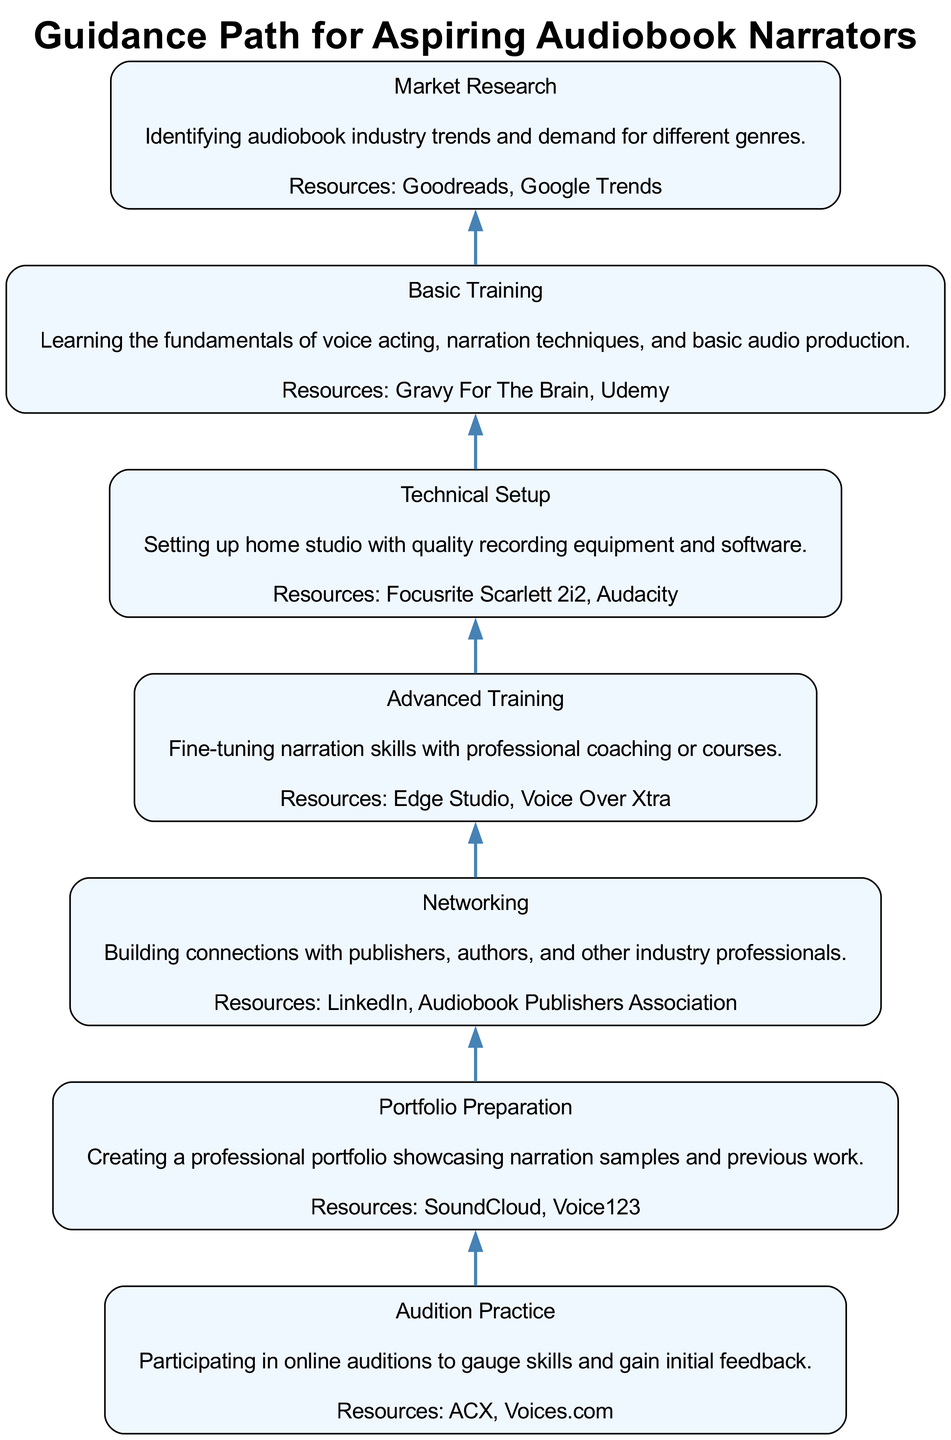What is the first step in the flow? The first step at the bottom of the diagram is "Market Research", as it represents the starting point for aspiring audiobook narrators before advancing to other skills and opportunities.
Answer: Market Research How many steps are there in total? By counting each individual step in the diagram from the bottom to the top, we find there are seven distinct steps listed, which guide aspiring narrators through their development and job search process.
Answer: 7 What is the last step in the flow? The last step at the top of the diagram is "Audition Practice", indicating the culminating activity where narrators can showcase their skills and receive feedback after acquiring various skills.
Answer: Audition Practice Which step directly precedes "Networking"? Upon reviewing the diagram, it is clear that "Portfolio Preparation" is the step that comes immediately before "Networking", indicating that narrators should prepare their portfolio prior to making industry connections.
Answer: Portfolio Preparation What type of resources are recommended for Basic Training? The diagram explicitly states that "Gravy For The Brain" and "Udemy" are the resources associated with the "Basic Training" step, which focuses on the fundamentals of narration techniques and acting.
Answer: Gravy For The Brain, Udemy What step involves setting up a home studio? In the diagram, "Technical Setup" is identified as the step focused on establishing a home recording environment with the necessary equipment, which is essential for producing quality audio content.
Answer: Technical Setup Which steps are part of skill-building before auditioning? Analyzing the flow, the steps "Basic Training," "Advanced Training," "Technical Setup," and "Portfolio Preparation" all contribute to skill development before reaching the "Audition Practice" stage.
Answer: Basic Training, Advanced Training, Technical Setup, Portfolio Preparation What is emphasized in the "Market Research" step? The description for "Market Research" highlights identifying industry trends and the demand for various audiobook genres, suggesting that this research is crucial for understanding the market landscape before engaging in narration.
Answer: Identifying trends and demand for genres Which resource is mentioned for Networking? According to the diagram, "LinkedIn" and "Audiobook Publishers Association" are both resources provided for the "Networking" step, indicating avenues for aspiring narrators to connect within the industry.
Answer: LinkedIn, Audiobook Publishers Association 